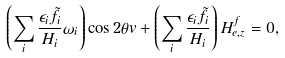Convert formula to latex. <formula><loc_0><loc_0><loc_500><loc_500>\left ( \sum _ { i } \frac { \epsilon _ { i } \tilde { f } _ { i } } { H _ { i } } \omega _ { i } \right ) \cos 2 \theta v + \left ( \sum _ { i } \frac { \epsilon _ { i } \tilde { f } _ { i } } { H _ { i } } \right ) H _ { e , z } ^ { f } = 0 ,</formula> 